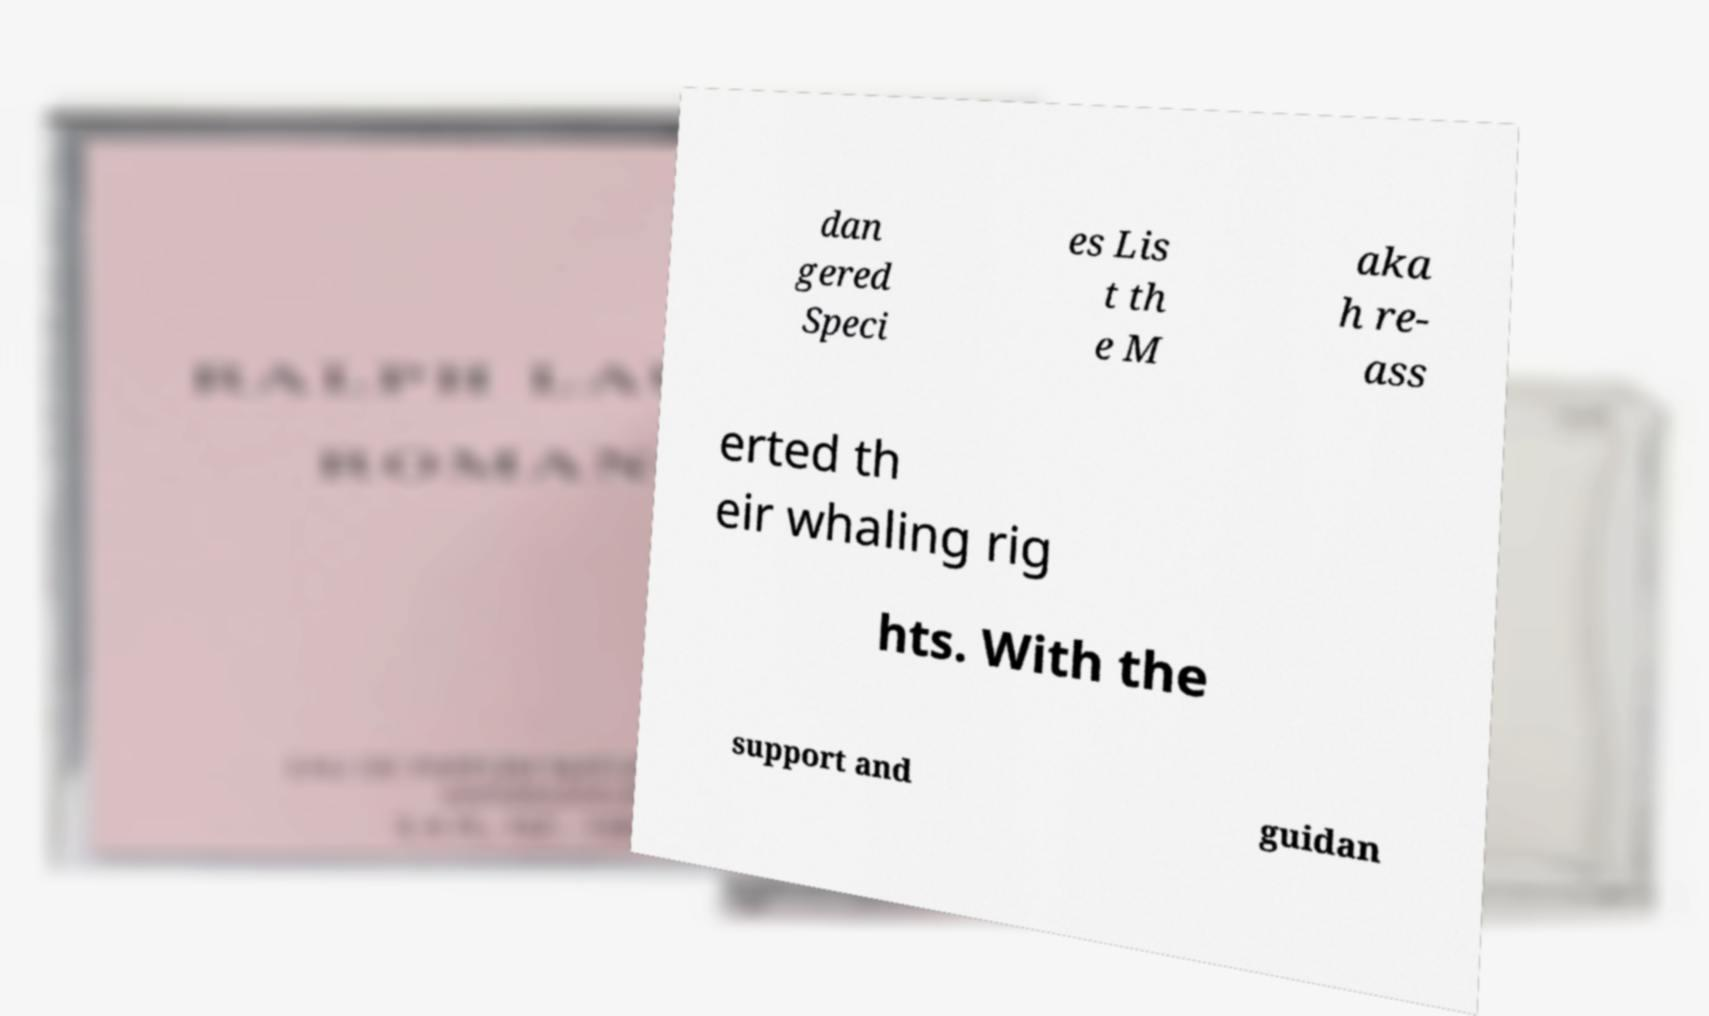Can you read and provide the text displayed in the image?This photo seems to have some interesting text. Can you extract and type it out for me? dan gered Speci es Lis t th e M aka h re- ass erted th eir whaling rig hts. With the support and guidan 